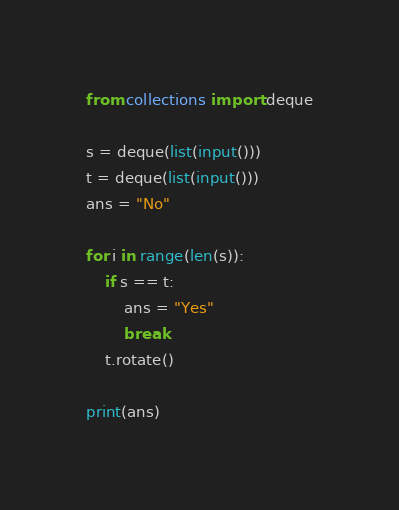Convert code to text. <code><loc_0><loc_0><loc_500><loc_500><_Python_>from collections import deque

s = deque(list(input()))
t = deque(list(input()))
ans = "No"

for i in range(len(s)):
    if s == t:
        ans = "Yes"
        break
    t.rotate()

print(ans)</code> 